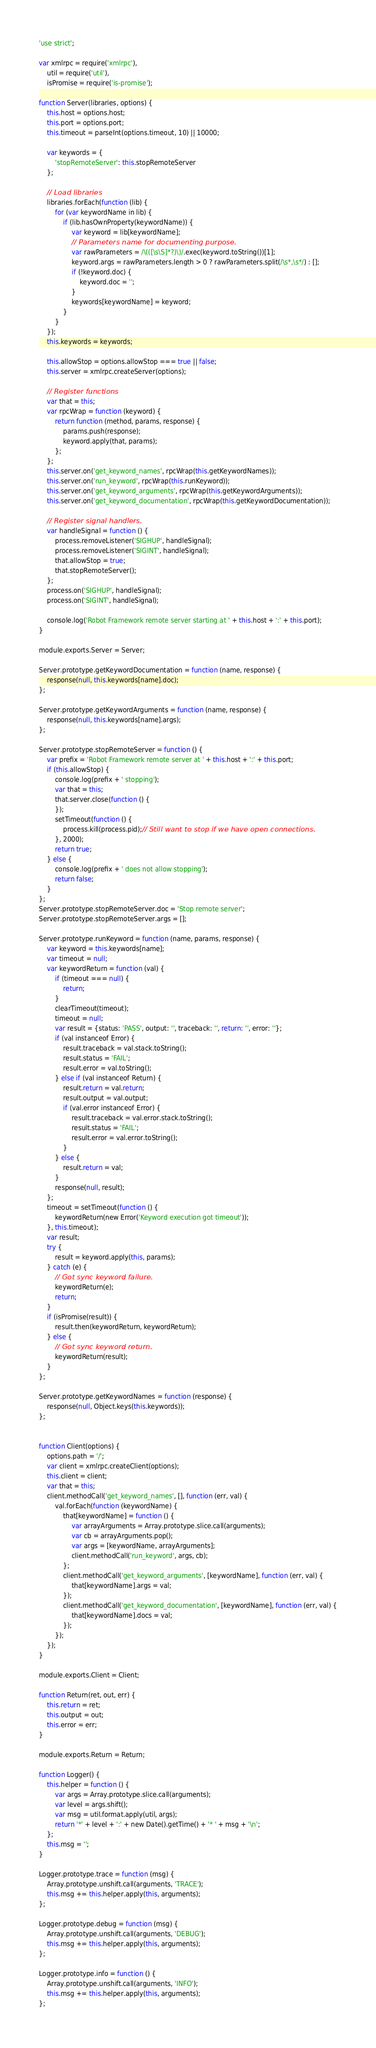<code> <loc_0><loc_0><loc_500><loc_500><_JavaScript_>'use strict';

var xmlrpc = require('xmlrpc'),
    util = require('util'),
    isPromise = require('is-promise');

function Server(libraries, options) {
    this.host = options.host;
    this.port = options.port;
    this.timeout = parseInt(options.timeout, 10) || 10000;

    var keywords = {
        'stopRemoteServer': this.stopRemoteServer
    };

    // Load libraries
    libraries.forEach(function (lib) {
        for (var keywordName in lib) {
            if (lib.hasOwnProperty(keywordName)) {
                var keyword = lib[keywordName];
                // Parameters name for documenting purpose.
                var rawParameters = /\(([\s\S]*?)\)/.exec(keyword.toString())[1];
                keyword.args = rawParameters.length > 0 ? rawParameters.split(/\s*,\s*/) : [];
                if (!keyword.doc) {
                    keyword.doc = '';
                }
                keywords[keywordName] = keyword;
            }
        }
    });
    this.keywords = keywords;

    this.allowStop = options.allowStop === true || false;
    this.server = xmlrpc.createServer(options);

    // Register functions
    var that = this;
    var rpcWrap = function (keyword) {
        return function (method, params, response) {
            params.push(response);
            keyword.apply(that, params);
        };
    };
    this.server.on('get_keyword_names', rpcWrap(this.getKeywordNames));
    this.server.on('run_keyword', rpcWrap(this.runKeyword));
    this.server.on('get_keyword_arguments', rpcWrap(this.getKeywordArguments));
    this.server.on('get_keyword_documentation', rpcWrap(this.getKeywordDocumentation));

    // Register signal handlers.
    var handleSignal = function () {
        process.removeListener('SIGHUP', handleSignal);
        process.removeListener('SIGINT', handleSignal);
        that.allowStop = true;
        that.stopRemoteServer();
    };
    process.on('SIGHUP', handleSignal);
    process.on('SIGINT', handleSignal);

    console.log('Robot Framework remote server starting at ' + this.host + ':' + this.port);
}

module.exports.Server = Server;

Server.prototype.getKeywordDocumentation = function (name, response) {
    response(null, this.keywords[name].doc);
};

Server.prototype.getKeywordArguments = function (name, response) {
    response(null, this.keywords[name].args);
};

Server.prototype.stopRemoteServer = function () {
    var prefix = 'Robot Framework remote server at ' + this.host + ':' + this.port;
    if (this.allowStop) {
        console.log(prefix + ' stopping');
        var that = this;
        that.server.close(function () {
        });
        setTimeout(function () {
            process.kill(process.pid);// Still want to stop if we have open connections.
        }, 2000);
        return true;
    } else {
        console.log(prefix + ' does not allow stopping');
        return false;
    }
};
Server.prototype.stopRemoteServer.doc = 'Stop remote server';
Server.prototype.stopRemoteServer.args = [];

Server.prototype.runKeyword = function (name, params, response) {
    var keyword = this.keywords[name];
    var timeout = null;
    var keywordReturn = function (val) {
        if (timeout === null) {
            return;
        }
        clearTimeout(timeout);
        timeout = null;
        var result = {status: 'PASS', output: '', traceback: '', return: '', error: ''};
        if (val instanceof Error) {
            result.traceback = val.stack.toString();
            result.status = 'FAIL';
            result.error = val.toString();
        } else if (val instanceof Return) {
            result.return = val.return;
            result.output = val.output;
            if (val.error instanceof Error) {
                result.traceback = val.error.stack.toString();
                result.status = 'FAIL';
                result.error = val.error.toString();
            }
        } else {
            result.return = val;
        }
        response(null, result);
    };
    timeout = setTimeout(function () {
        keywordReturn(new Error('Keyword execution got timeout'));
    }, this.timeout);
    var result;
    try {
        result = keyword.apply(this, params);
    } catch (e) {
        // Got sync keyword failure.
        keywordReturn(e);
        return;
    }
    if (isPromise(result)) {
        result.then(keywordReturn, keywordReturn);
    } else {
        // Got sync keyword return.
        keywordReturn(result);
    }
};

Server.prototype.getKeywordNames = function (response) {
    response(null, Object.keys(this.keywords));
};


function Client(options) {
    options.path = '/';
    var client = xmlrpc.createClient(options);
    this.client = client;
    var that = this;
    client.methodCall('get_keyword_names', [], function (err, val) {
        val.forEach(function (keywordName) {
            that[keywordName] = function () {
                var arrayArguments = Array.prototype.slice.call(arguments);
                var cb = arrayArguments.pop();
                var args = [keywordName, arrayArguments];
                client.methodCall('run_keyword', args, cb);
            };
            client.methodCall('get_keyword_arguments', [keywordName], function (err, val) {
                that[keywordName].args = val;
            });
            client.methodCall('get_keyword_documentation', [keywordName], function (err, val) {
                that[keywordName].docs = val;
            });
        });
    });
}

module.exports.Client = Client;

function Return(ret, out, err) {
    this.return = ret;
    this.output = out;
    this.error = err;
}

module.exports.Return = Return;

function Logger() {
    this.helper = function () {
        var args = Array.prototype.slice.call(arguments);
        var level = args.shift();
        var msg = util.format.apply(util, args);
        return '*' + level + ':' + new Date().getTime() + '* ' + msg + '\n';
    };
    this.msg = '';
}

Logger.prototype.trace = function (msg) {
    Array.prototype.unshift.call(arguments, 'TRACE');
    this.msg += this.helper.apply(this, arguments);
};

Logger.prototype.debug = function (msg) {
    Array.prototype.unshift.call(arguments, 'DEBUG');
    this.msg += this.helper.apply(this, arguments);
};

Logger.prototype.info = function () {
    Array.prototype.unshift.call(arguments, 'INFO');
    this.msg += this.helper.apply(this, arguments);
};
</code> 